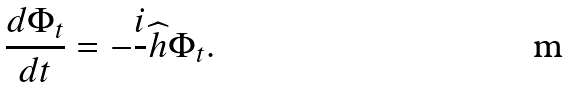Convert formula to latex. <formula><loc_0><loc_0><loc_500><loc_500>\frac { d \Phi _ { t } } { d t } = - \frac { i } { } { \widehat { h } } \Phi _ { t } .</formula> 